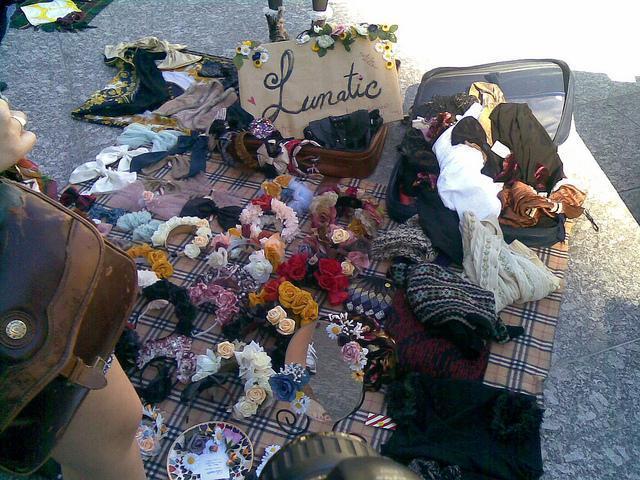Which type flower is most oft repeated here?
Choose the right answer from the provided options to respond to the question.
Options: Gladiola, daisy, rose, iris. Rose. 